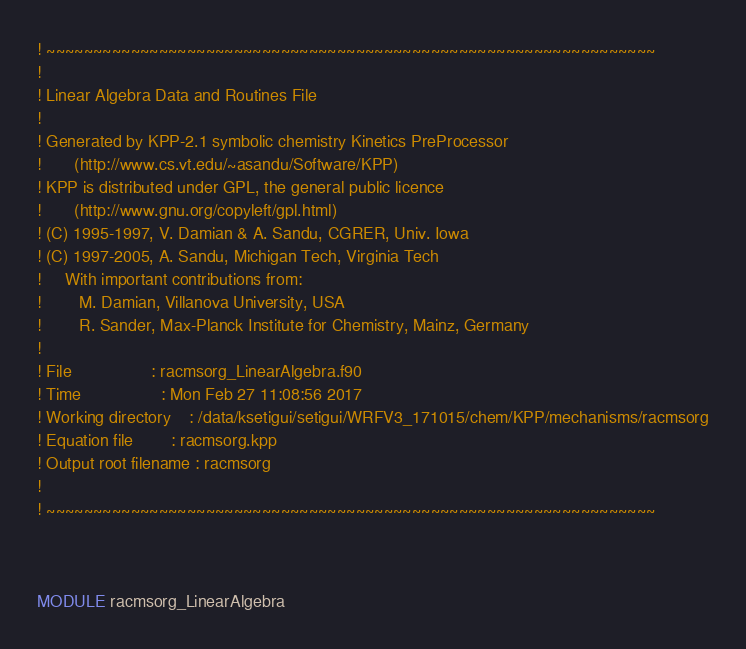Convert code to text. <code><loc_0><loc_0><loc_500><loc_500><_FORTRAN_>! ~~~~~~~~~~~~~~~~~~~~~~~~~~~~~~~~~~~~~~~~~~~~~~~~~~~~~~~~~~~~~~~~~
! 
! Linear Algebra Data and Routines File
! 
! Generated by KPP-2.1 symbolic chemistry Kinetics PreProcessor
!       (http://www.cs.vt.edu/~asandu/Software/KPP)
! KPP is distributed under GPL, the general public licence
!       (http://www.gnu.org/copyleft/gpl.html)
! (C) 1995-1997, V. Damian & A. Sandu, CGRER, Univ. Iowa
! (C) 1997-2005, A. Sandu, Michigan Tech, Virginia Tech
!     With important contributions from:
!        M. Damian, Villanova University, USA
!        R. Sander, Max-Planck Institute for Chemistry, Mainz, Germany
! 
! File                 : racmsorg_LinearAlgebra.f90
! Time                 : Mon Feb 27 11:08:56 2017
! Working directory    : /data/ksetigui/setigui/WRFV3_171015/chem/KPP/mechanisms/racmsorg
! Equation file        : racmsorg.kpp
! Output root filename : racmsorg
! 
! ~~~~~~~~~~~~~~~~~~~~~~~~~~~~~~~~~~~~~~~~~~~~~~~~~~~~~~~~~~~~~~~~~



MODULE racmsorg_LinearAlgebra
</code> 